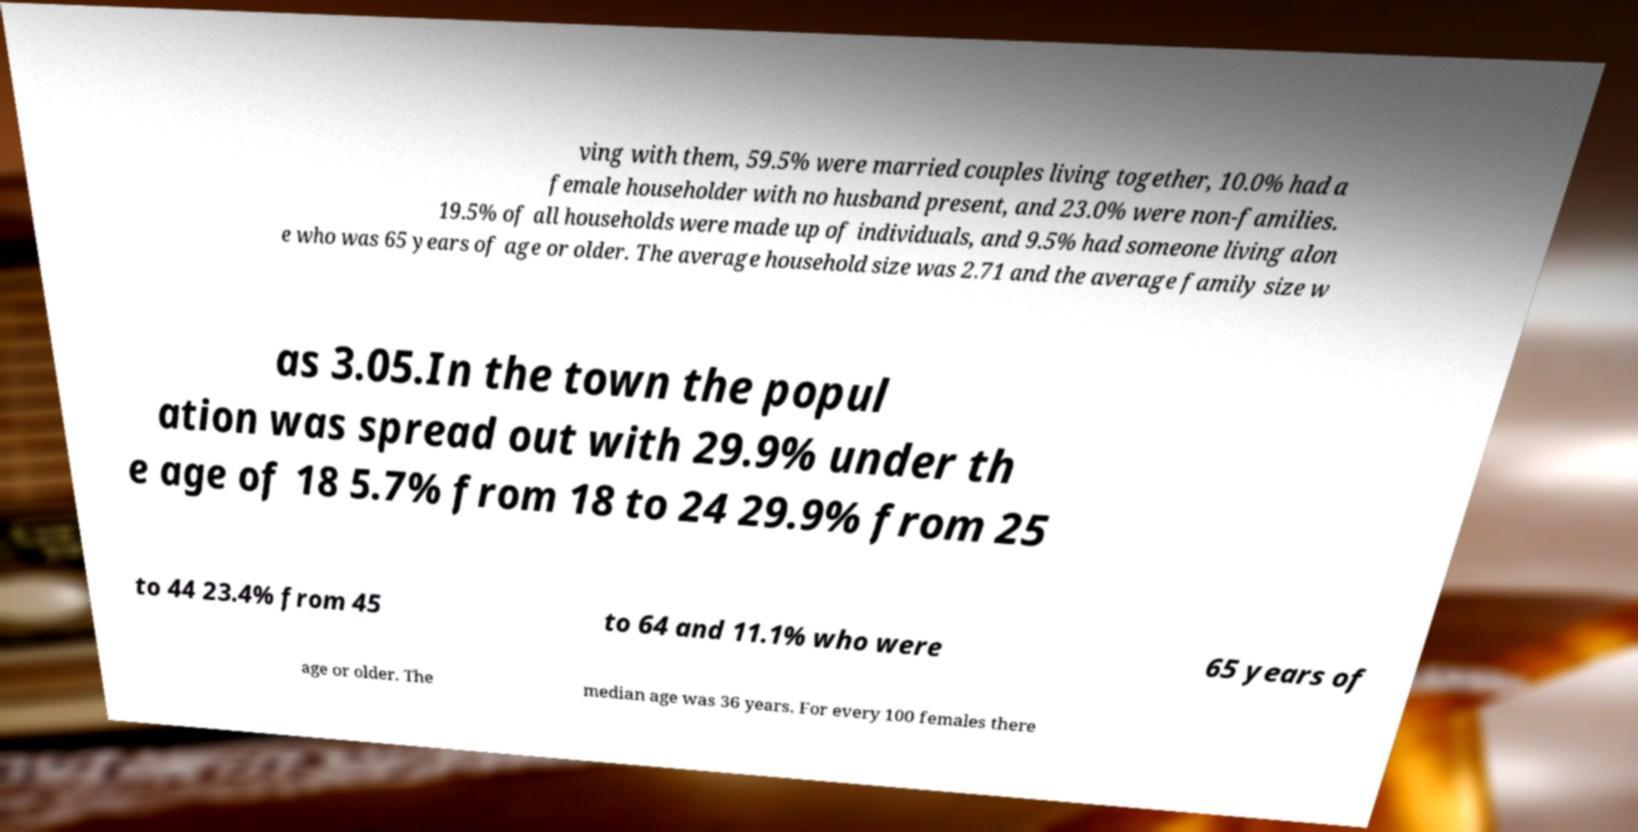Please identify and transcribe the text found in this image. ving with them, 59.5% were married couples living together, 10.0% had a female householder with no husband present, and 23.0% were non-families. 19.5% of all households were made up of individuals, and 9.5% had someone living alon e who was 65 years of age or older. The average household size was 2.71 and the average family size w as 3.05.In the town the popul ation was spread out with 29.9% under th e age of 18 5.7% from 18 to 24 29.9% from 25 to 44 23.4% from 45 to 64 and 11.1% who were 65 years of age or older. The median age was 36 years. For every 100 females there 